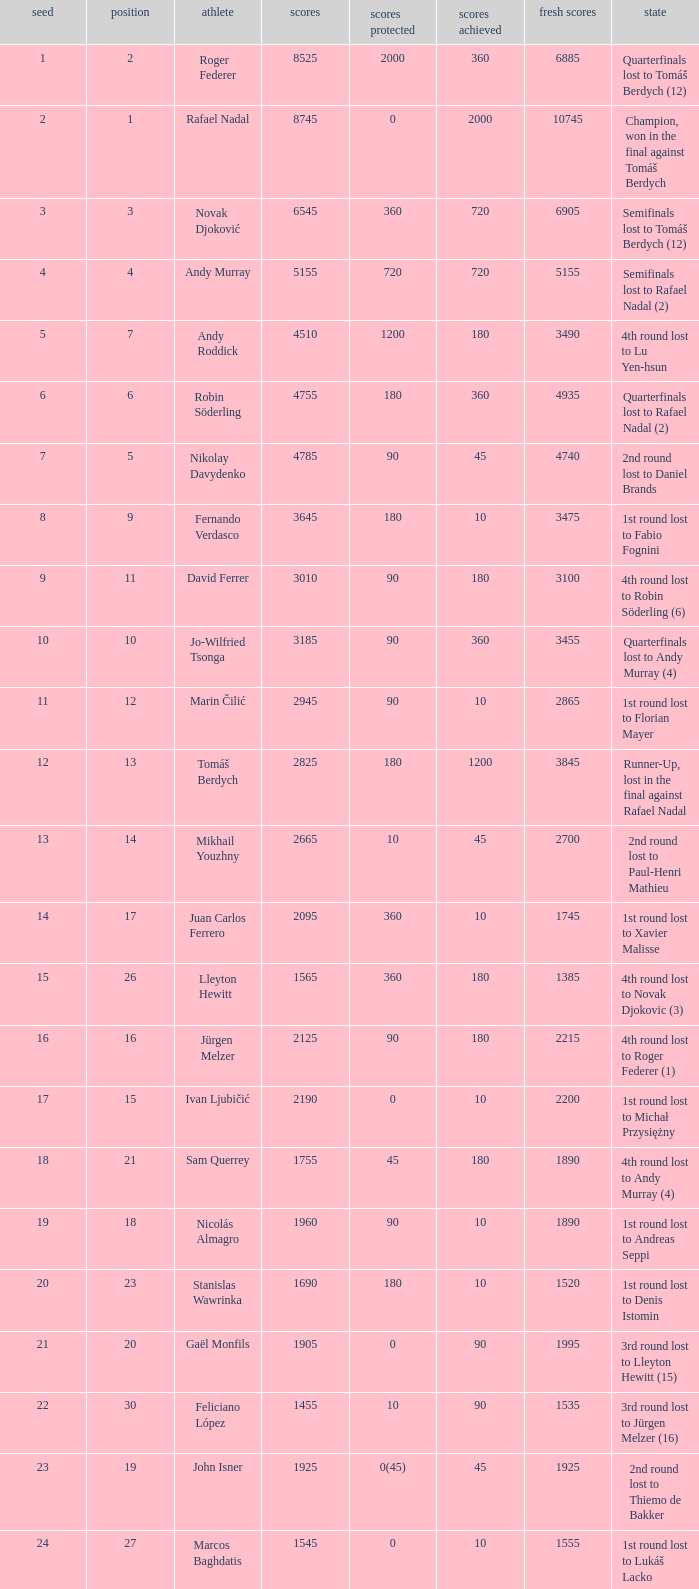Name the number of points defending for 1075 1.0. Help me parse the entirety of this table. {'header': ['seed', 'position', 'athlete', 'scores', 'scores protected', 'scores achieved', 'fresh scores', 'state'], 'rows': [['1', '2', 'Roger Federer', '8525', '2000', '360', '6885', 'Quarterfinals lost to Tomáš Berdych (12)'], ['2', '1', 'Rafael Nadal', '8745', '0', '2000', '10745', 'Champion, won in the final against Tomáš Berdych'], ['3', '3', 'Novak Djoković', '6545', '360', '720', '6905', 'Semifinals lost to Tomáš Berdych (12)'], ['4', '4', 'Andy Murray', '5155', '720', '720', '5155', 'Semifinals lost to Rafael Nadal (2)'], ['5', '7', 'Andy Roddick', '4510', '1200', '180', '3490', '4th round lost to Lu Yen-hsun'], ['6', '6', 'Robin Söderling', '4755', '180', '360', '4935', 'Quarterfinals lost to Rafael Nadal (2)'], ['7', '5', 'Nikolay Davydenko', '4785', '90', '45', '4740', '2nd round lost to Daniel Brands'], ['8', '9', 'Fernando Verdasco', '3645', '180', '10', '3475', '1st round lost to Fabio Fognini'], ['9', '11', 'David Ferrer', '3010', '90', '180', '3100', '4th round lost to Robin Söderling (6)'], ['10', '10', 'Jo-Wilfried Tsonga', '3185', '90', '360', '3455', 'Quarterfinals lost to Andy Murray (4)'], ['11', '12', 'Marin Čilić', '2945', '90', '10', '2865', '1st round lost to Florian Mayer'], ['12', '13', 'Tomáš Berdych', '2825', '180', '1200', '3845', 'Runner-Up, lost in the final against Rafael Nadal'], ['13', '14', 'Mikhail Youzhny', '2665', '10', '45', '2700', '2nd round lost to Paul-Henri Mathieu'], ['14', '17', 'Juan Carlos Ferrero', '2095', '360', '10', '1745', '1st round lost to Xavier Malisse'], ['15', '26', 'Lleyton Hewitt', '1565', '360', '180', '1385', '4th round lost to Novak Djokovic (3)'], ['16', '16', 'Jürgen Melzer', '2125', '90', '180', '2215', '4th round lost to Roger Federer (1)'], ['17', '15', 'Ivan Ljubičić', '2190', '0', '10', '2200', '1st round lost to Michał Przysiężny'], ['18', '21', 'Sam Querrey', '1755', '45', '180', '1890', '4th round lost to Andy Murray (4)'], ['19', '18', 'Nicolás Almagro', '1960', '90', '10', '1890', '1st round lost to Andreas Seppi'], ['20', '23', 'Stanislas Wawrinka', '1690', '180', '10', '1520', '1st round lost to Denis Istomin'], ['21', '20', 'Gaël Monfils', '1905', '0', '90', '1995', '3rd round lost to Lleyton Hewitt (15)'], ['22', '30', 'Feliciano López', '1455', '10', '90', '1535', '3rd round lost to Jürgen Melzer (16)'], ['23', '19', 'John Isner', '1925', '0(45)', '45', '1925', '2nd round lost to Thiemo de Bakker'], ['24', '27', 'Marcos Baghdatis', '1545', '0', '10', '1555', '1st round lost to Lukáš Lacko'], ['25', '24', 'Thomaz Bellucci', '1652', '0(20)', '90', '1722', '3rd round lost to Robin Söderling (6)'], ['26', '32', 'Gilles Simon', '1305', '180', '90', '1215', '3rd round lost to Andy Murray (4)'], ['28', '31', 'Albert Montañés', '1405', '90', '90', '1405', '3rd round lost to Novak Djokovic (3)'], ['29', '35', 'Philipp Kohlschreiber', '1230', '90', '90', '1230', '3rd round lost to Andy Roddick (5)'], ['30', '36', 'Tommy Robredo', '1155', '90', '10', '1075', '1st round lost to Peter Luczak'], ['31', '37', 'Victor Hănescu', '1070', '45', '90', '1115', '3rd round lost to Daniel Brands'], ['32', '38', 'Julien Benneteau', '1059', '10', '180', '1229', '4th round lost to Jo-Wilfried Tsonga (10)']]} 